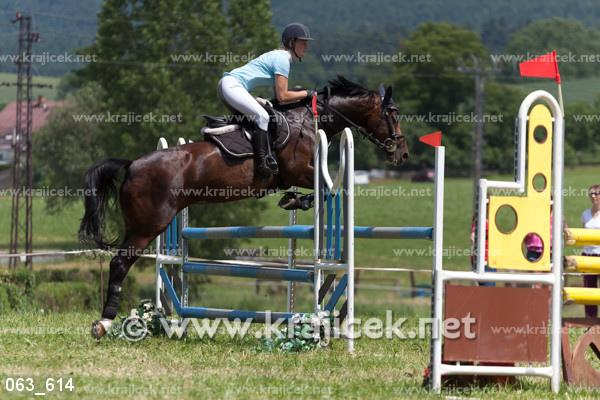What is this horse practicing?

Choices:
A) steeplechase
B) escape
C) posing
D) bucking steeplechase 